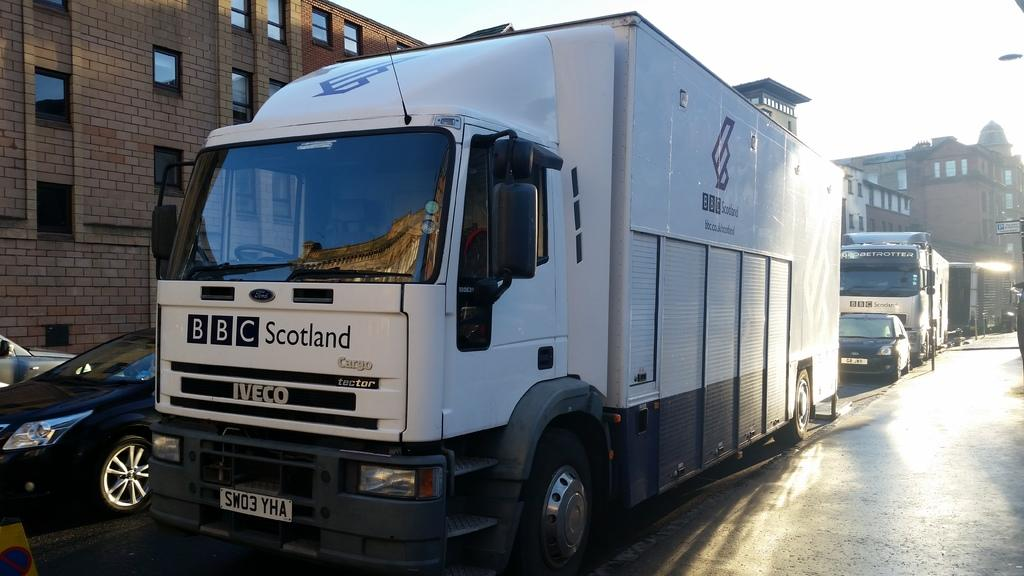What is located in the center of the image? There are vehicles in the center of the image. What is at the bottom of the image? There is a road at the bottom of the image. What can be seen in the background of the image? There are buildings and poles in the background of the image. What is visible at the top of the image? The sky is visible at the top of the image. Who is teaching the sack to perform tricks in the image? There is no sack or teaching activity present in the image. What is the self doing in the image? There is no reference to a self or any self-related activity in the image. 